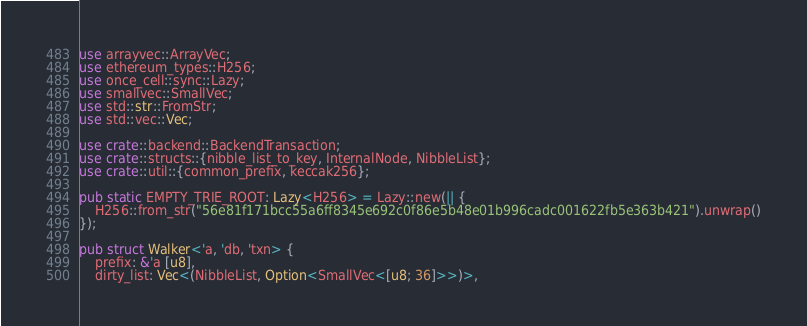<code> <loc_0><loc_0><loc_500><loc_500><_Rust_>use arrayvec::ArrayVec;
use ethereum_types::H256;
use once_cell::sync::Lazy;
use smallvec::SmallVec;
use std::str::FromStr;
use std::vec::Vec;

use crate::backend::BackendTransaction;
use crate::structs::{nibble_list_to_key, InternalNode, NibbleList};
use crate::util::{common_prefix, keccak256};

pub static EMPTY_TRIE_ROOT: Lazy<H256> = Lazy::new(|| {
    H256::from_str("56e81f171bcc55a6ff8345e692c0f86e5b48e01b996cadc001622fb5e363b421").unwrap()
});

pub struct Walker<'a, 'db, 'txn> {
    prefix: &'a [u8],
    dirty_list: Vec<(NibbleList, Option<SmallVec<[u8; 36]>>)>,</code> 